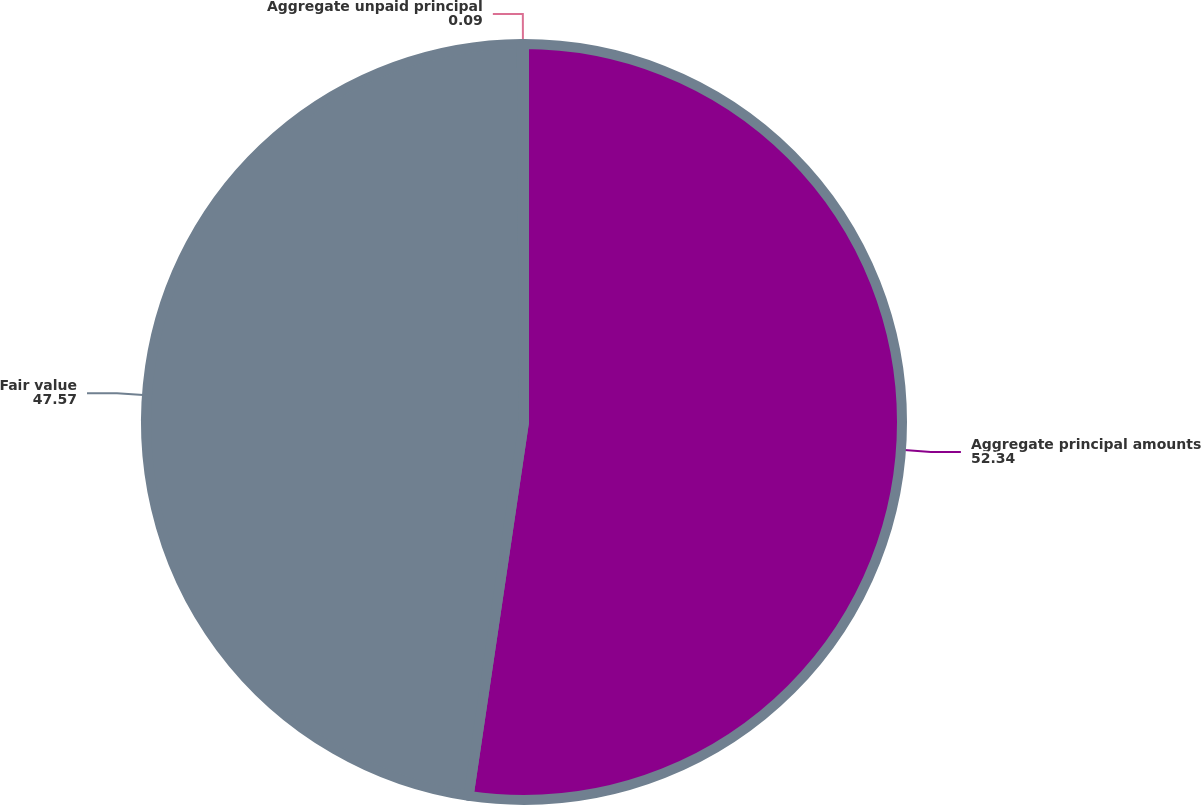Convert chart to OTSL. <chart><loc_0><loc_0><loc_500><loc_500><pie_chart><fcel>Aggregate principal amounts<fcel>Fair value<fcel>Aggregate unpaid principal<nl><fcel>52.34%<fcel>47.57%<fcel>0.09%<nl></chart> 